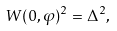Convert formula to latex. <formula><loc_0><loc_0><loc_500><loc_500>W ( 0 , \varphi ) ^ { 2 } = \Delta ^ { 2 } ,</formula> 